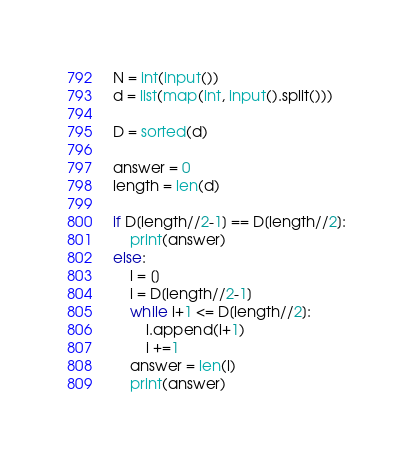Convert code to text. <code><loc_0><loc_0><loc_500><loc_500><_Python_>N = int(input())
d = list(map(int, input().split()))

D = sorted(d)

answer = 0
length = len(d)

if D[length//2-1] == D[length//2]:
    print(answer)
else:
    l = []
    i = D[length//2-1]
    while i+1 <= D[length//2]:
        l.append(i+1)
        i +=1
    answer = len(l)
    print(answer)
</code> 